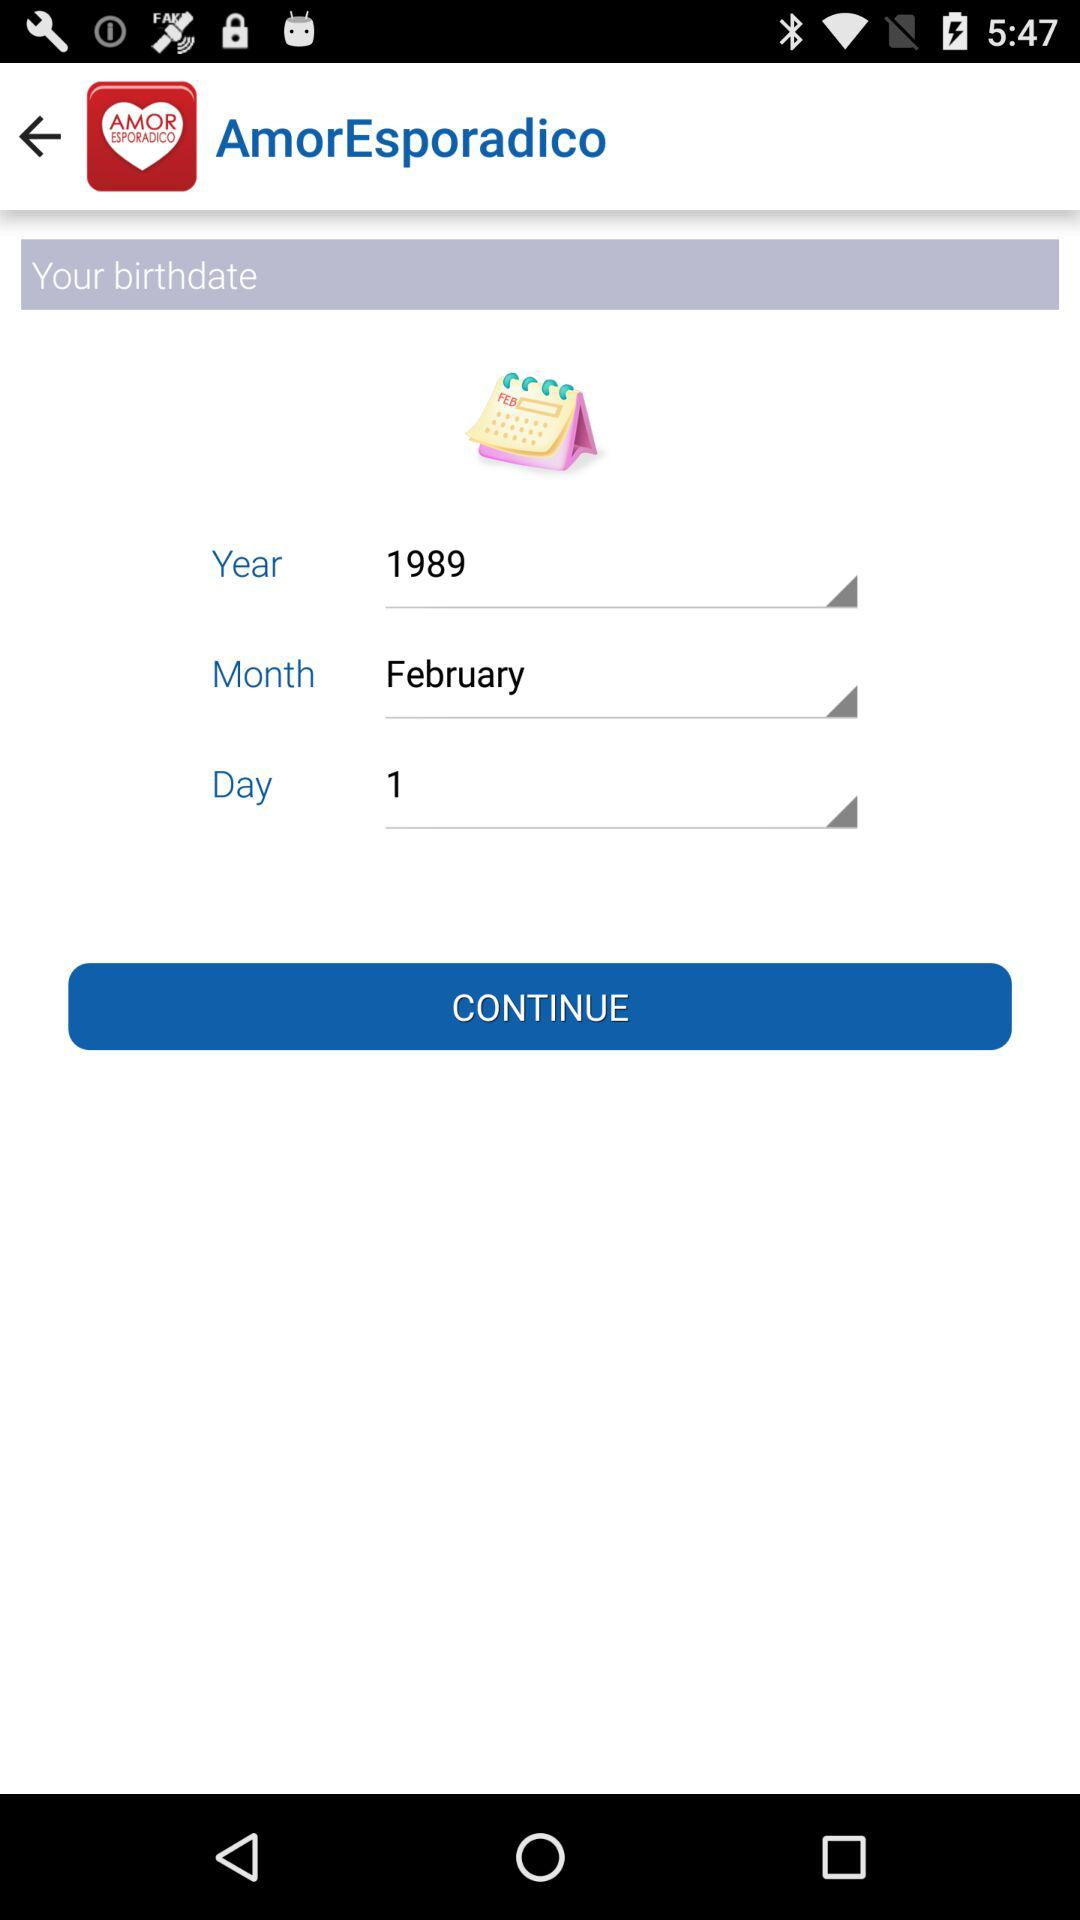How many text inputs are there for the birthdate?
Answer the question using a single word or phrase. 3 